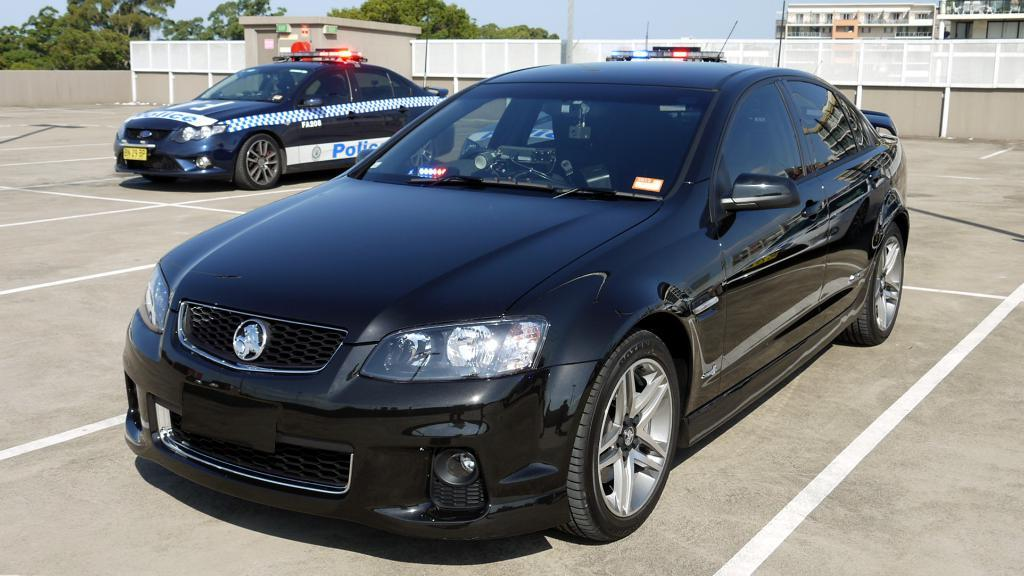What types of objects can be seen in the image? There are vehicles in the image. What type of structure is present in the image? There is a shed in the image. What material is the fencing made of in the image? The fencing in the image is made of metal. What type of natural elements can be seen in the image? There are trees in the image. What part of the natural environment is visible in the image? The sky is visible in the image. What type of marble is used to decorate the shed in the image? There is no marble present in the image, and the shed is not described as being decorated with marble. What type of linen is draped over the vehicles in the image? There is no linen present in the image, and the vehicles are not described as being covered with linen. 